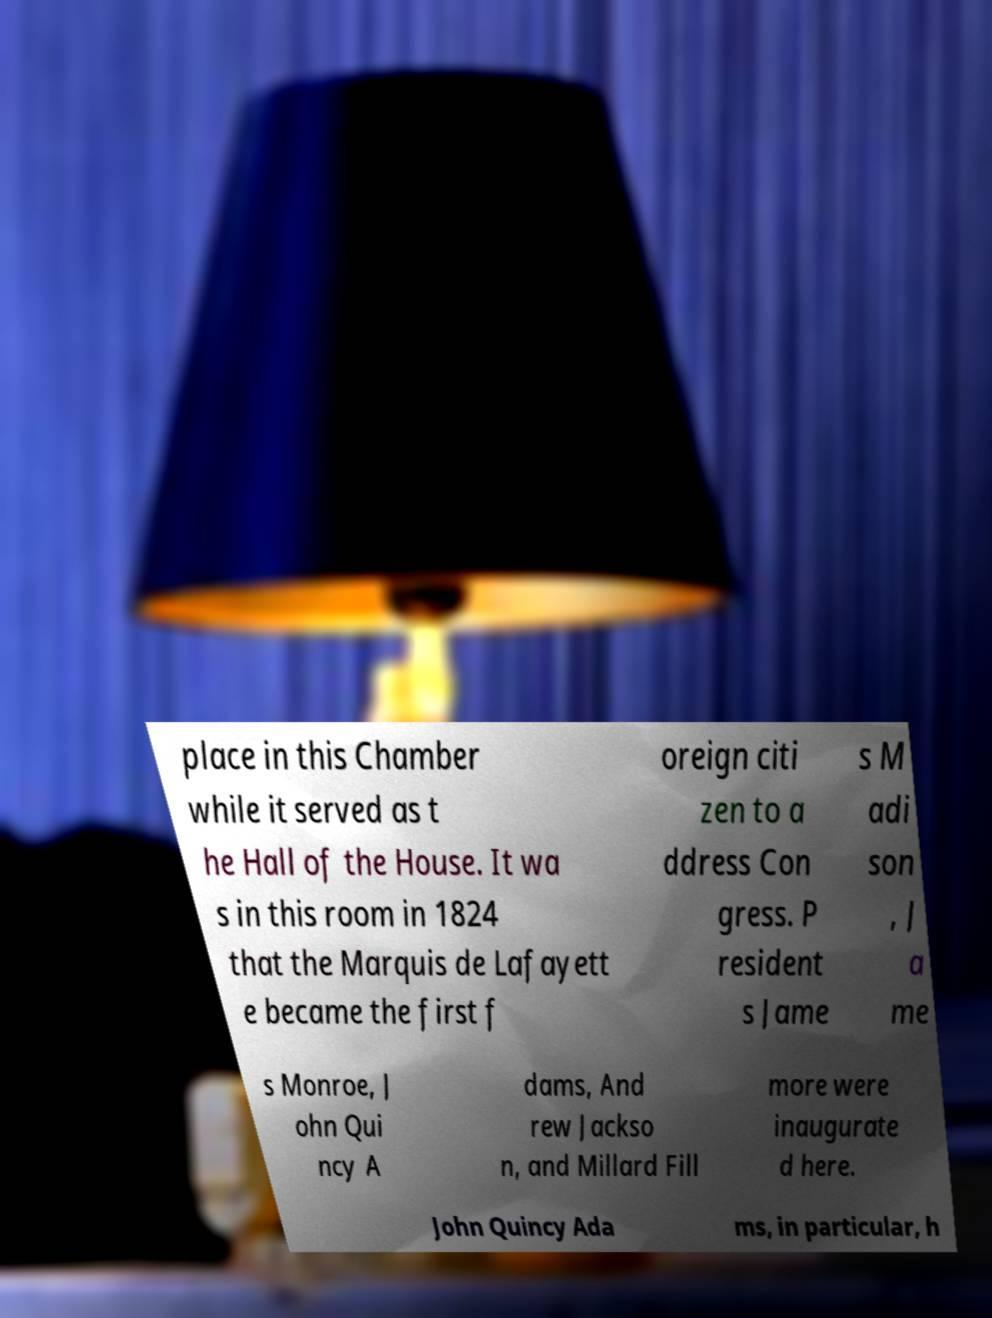Could you extract and type out the text from this image? place in this Chamber while it served as t he Hall of the House. It wa s in this room in 1824 that the Marquis de Lafayett e became the first f oreign citi zen to a ddress Con gress. P resident s Jame s M adi son , J a me s Monroe, J ohn Qui ncy A dams, And rew Jackso n, and Millard Fill more were inaugurate d here. John Quincy Ada ms, in particular, h 